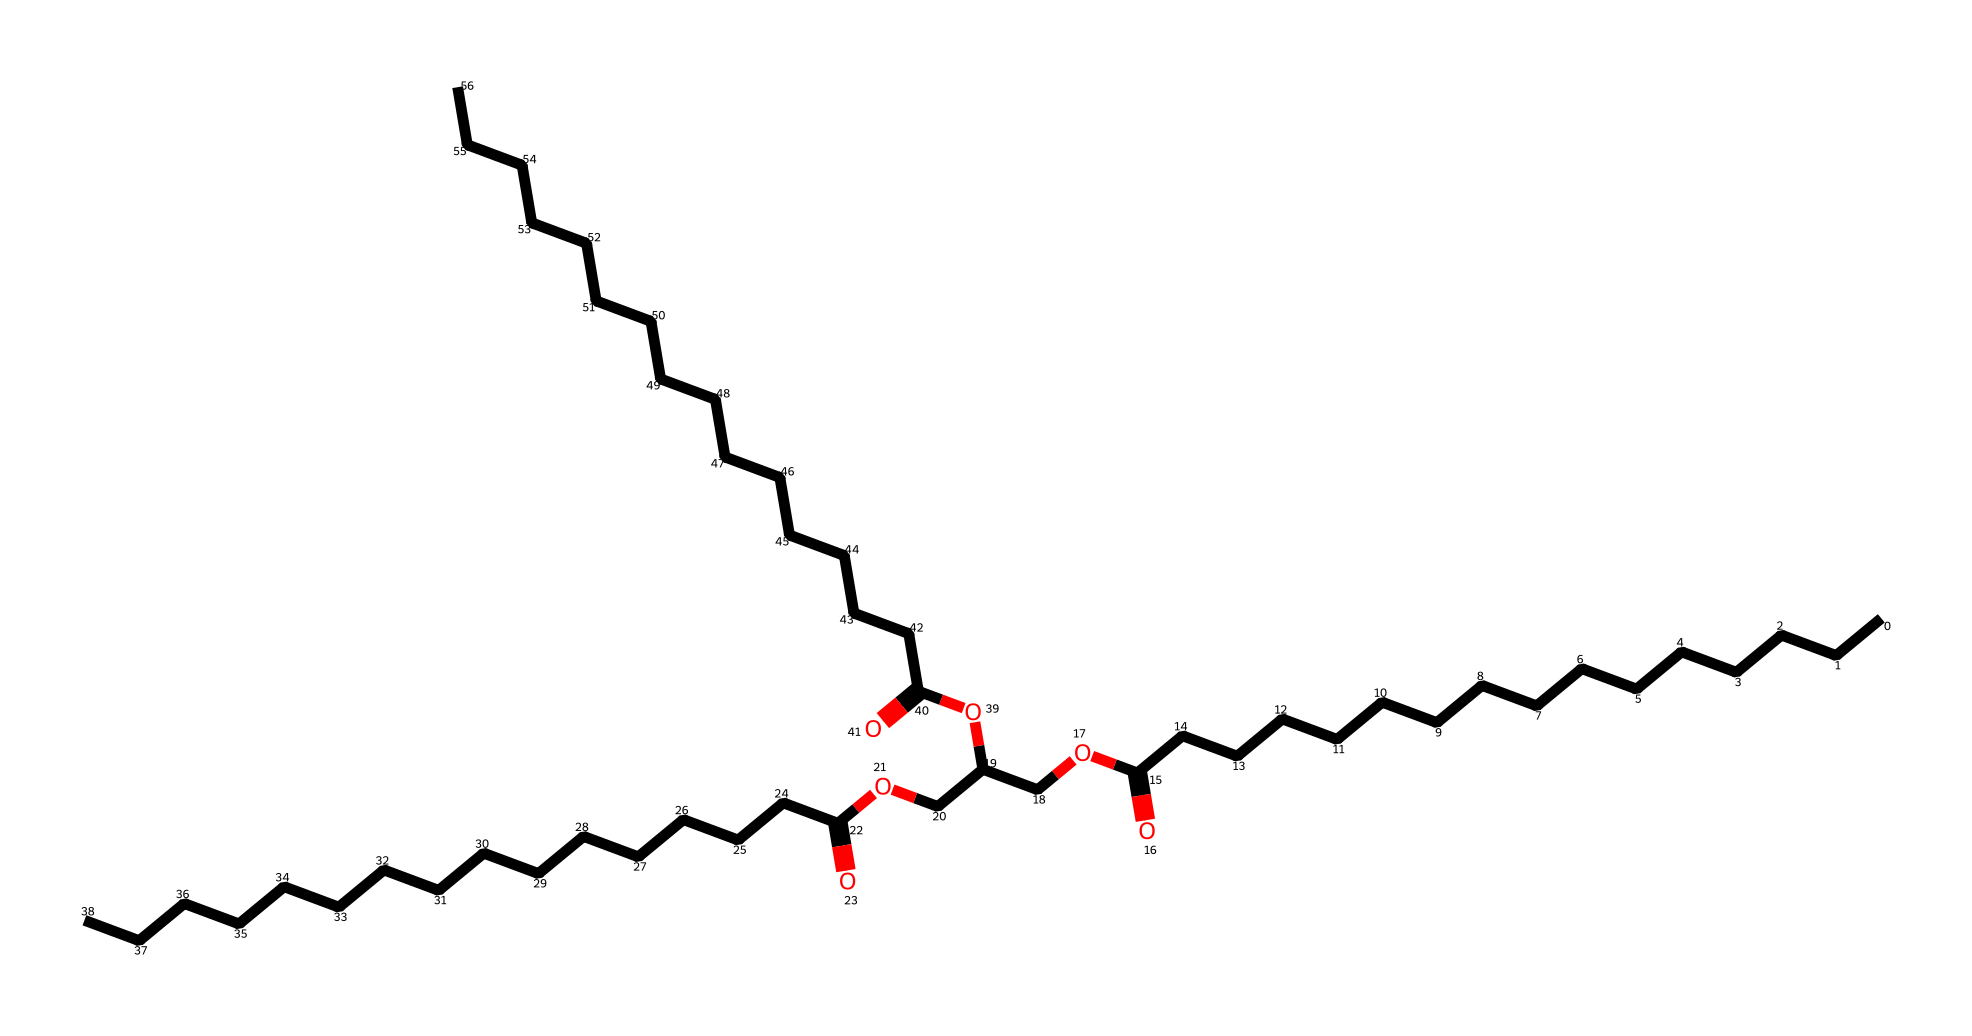what is the primary functional group present in this molecule? The chemical structure includes carbonyl (C=O) and hydroxyl (–OH) groups, but the key functional group of tallow is the ester group, as indicated by the –O– linkage to carbon chains.
Answer: ester how many carbon atoms are present in the longest chain of this lipid? By analyzing the longest continuous carbon chain, there are 18 carbon atoms in the longest chain. This is evident from counting along the carbon backbone shown in the structure.
Answer: 18 what type of lipid is represented by this chemical structure? This structure depicts a triglyceride, which is a common type of lipid formed by the esterification of glycerol with three fatty acids, observable in the three ester bonds.
Answer: triglyceride how many ester bonds are present in this molecule? The structure shows that there are three ester bonds where fatty acids are attached to glycerol, recognizable by the connectivity of the ester functional groups.
Answer: 3 which characteristic of this lipid contributes to its ability to solidify at room temperature? The presence of long saturated fatty acid chains in the structure leads to higher melting points and enhanced solidification at room temperature, as these straight chains pack closely together.
Answer: saturated fatty acids how does the molecular structure relate to its use in candle-making during the Founding Fathers' era? The long carbon chains in the triglyceride structure allow for a stable, solid form at room temperature, providing a suitable base for wax and efficient burning in candle-making, foundational to stable fuel sources at the time.
Answer: stable fuel source 